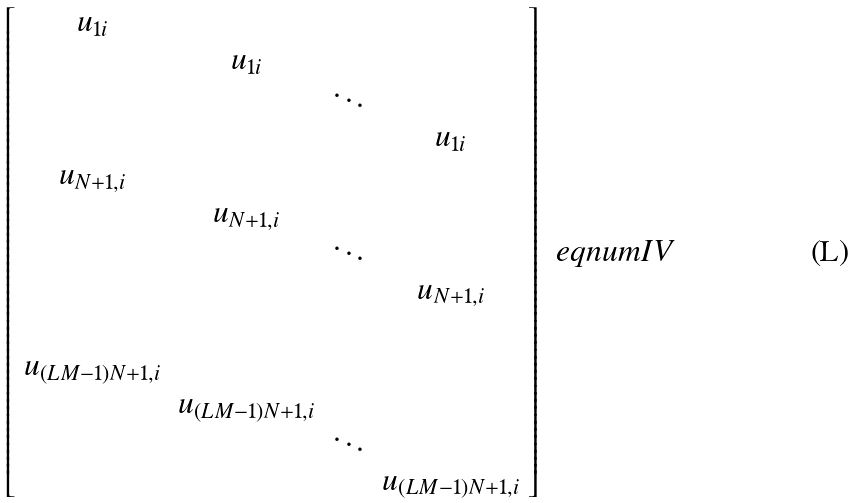Convert formula to latex. <formula><loc_0><loc_0><loc_500><loc_500>\left [ \begin{array} { c c c c } u _ { 1 i } & & & \\ & u _ { 1 i } & & \\ & & \ddots & \\ & & & u _ { 1 i } \\ u _ { N + 1 , i } & & & \\ & u _ { N + 1 , i } & & \\ & & \ddots & \\ & & & u _ { N + 1 , i } \\ & & & \\ u _ { ( L M - 1 ) N + 1 , i } & & & \\ & u _ { ( L M - 1 ) N + 1 , i } & & \\ & & \ddots & \\ & & & u _ { ( L M - 1 ) N + 1 , i } \end{array} \right ] \ e q n u m { I V }</formula> 